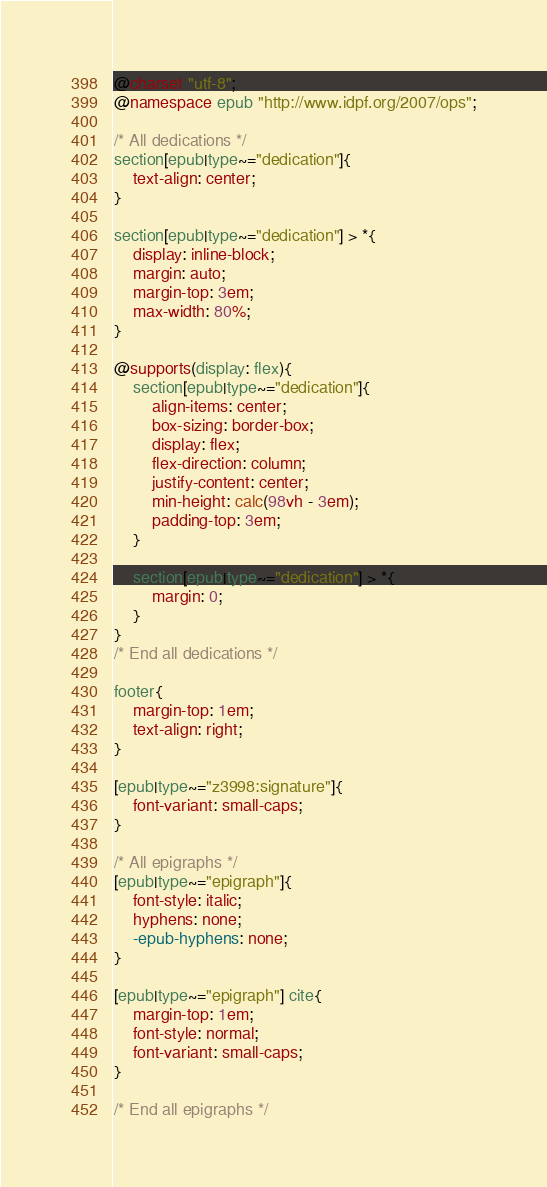Convert code to text. <code><loc_0><loc_0><loc_500><loc_500><_CSS_>@charset "utf-8";
@namespace epub "http://www.idpf.org/2007/ops";

/* All dedications */
section[epub|type~="dedication"]{
	text-align: center;
}

section[epub|type~="dedication"] > *{
	display: inline-block;
	margin: auto;
	margin-top: 3em;
	max-width: 80%;
}

@supports(display: flex){
	section[epub|type~="dedication"]{
		align-items: center;
		box-sizing: border-box;
		display: flex;
		flex-direction: column;
		justify-content: center;
		min-height: calc(98vh - 3em);
		padding-top: 3em;
	}

	section[epub|type~="dedication"] > *{
		margin: 0;
	}
}
/* End all dedications */

footer{
	margin-top: 1em;
	text-align: right;
}

[epub|type~="z3998:signature"]{
	font-variant: small-caps;
}

/* All epigraphs */
[epub|type~="epigraph"]{
	font-style: italic;
	hyphens: none;
	-epub-hyphens: none;
}

[epub|type~="epigraph"] cite{
	margin-top: 1em;
	font-style: normal;
	font-variant: small-caps;
}

/* End all epigraphs */</code> 